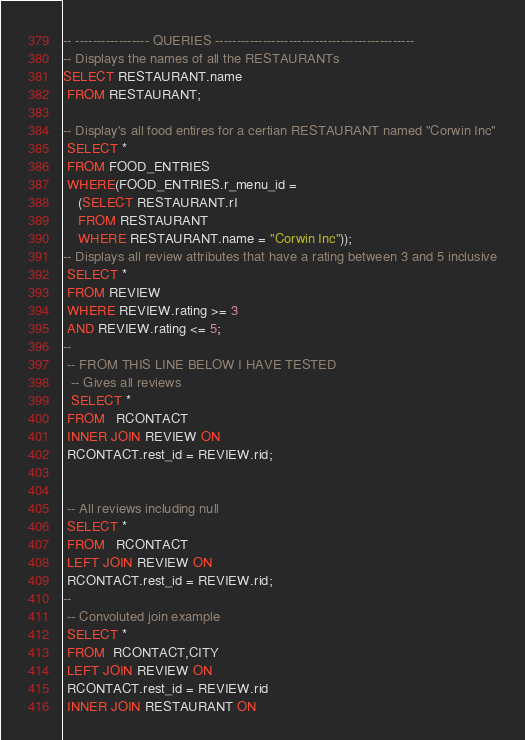<code> <loc_0><loc_0><loc_500><loc_500><_SQL_>-- ----------------- QUERIES ----------------------------------------------
-- Displays the names of all the RESTAURANTs
SELECT RESTAURANT.name
 FROM RESTAURANT;
 
-- Display's all food entires for a certian RESTAURANT named "Corwin Inc"
 SELECT *
 FROM FOOD_ENTRIES
 WHERE(FOOD_ENTRIES.r_menu_id = 
	(SELECT RESTAURANT.rI
    FROM RESTAURANT
    WHERE RESTAURANT.name = "Corwin Inc"));
-- Displays all review attributes that have a rating between 3 and 5 inclusive
 SELECT *
 FROM REVIEW
 WHERE REVIEW.rating >= 3 
 AND REVIEW.rating <= 5;
--
 -- FROM THIS LINE BELOW I HAVE TESTED
  -- Gives all reviews
  SELECT *
 FROM   RCONTACT
 INNER JOIN REVIEW ON
 RCONTACT.rest_id = REVIEW.rid;
 
 
 -- All reviews including null
 SELECT *
 FROM   RCONTACT
 LEFT JOIN REVIEW ON
 RCONTACT.rest_id = REVIEW.rid;
--
 -- Convoluted join example
 SELECT *
 FROM  RCONTACT,CITY
 LEFT JOIN REVIEW ON
 RCONTACT.rest_id = REVIEW.rid
 INNER JOIN RESTAURANT ON</code> 